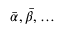Convert formula to latex. <formula><loc_0><loc_0><loc_500><loc_500>\bar { \alpha } , \bar { \beta } , \dots</formula> 